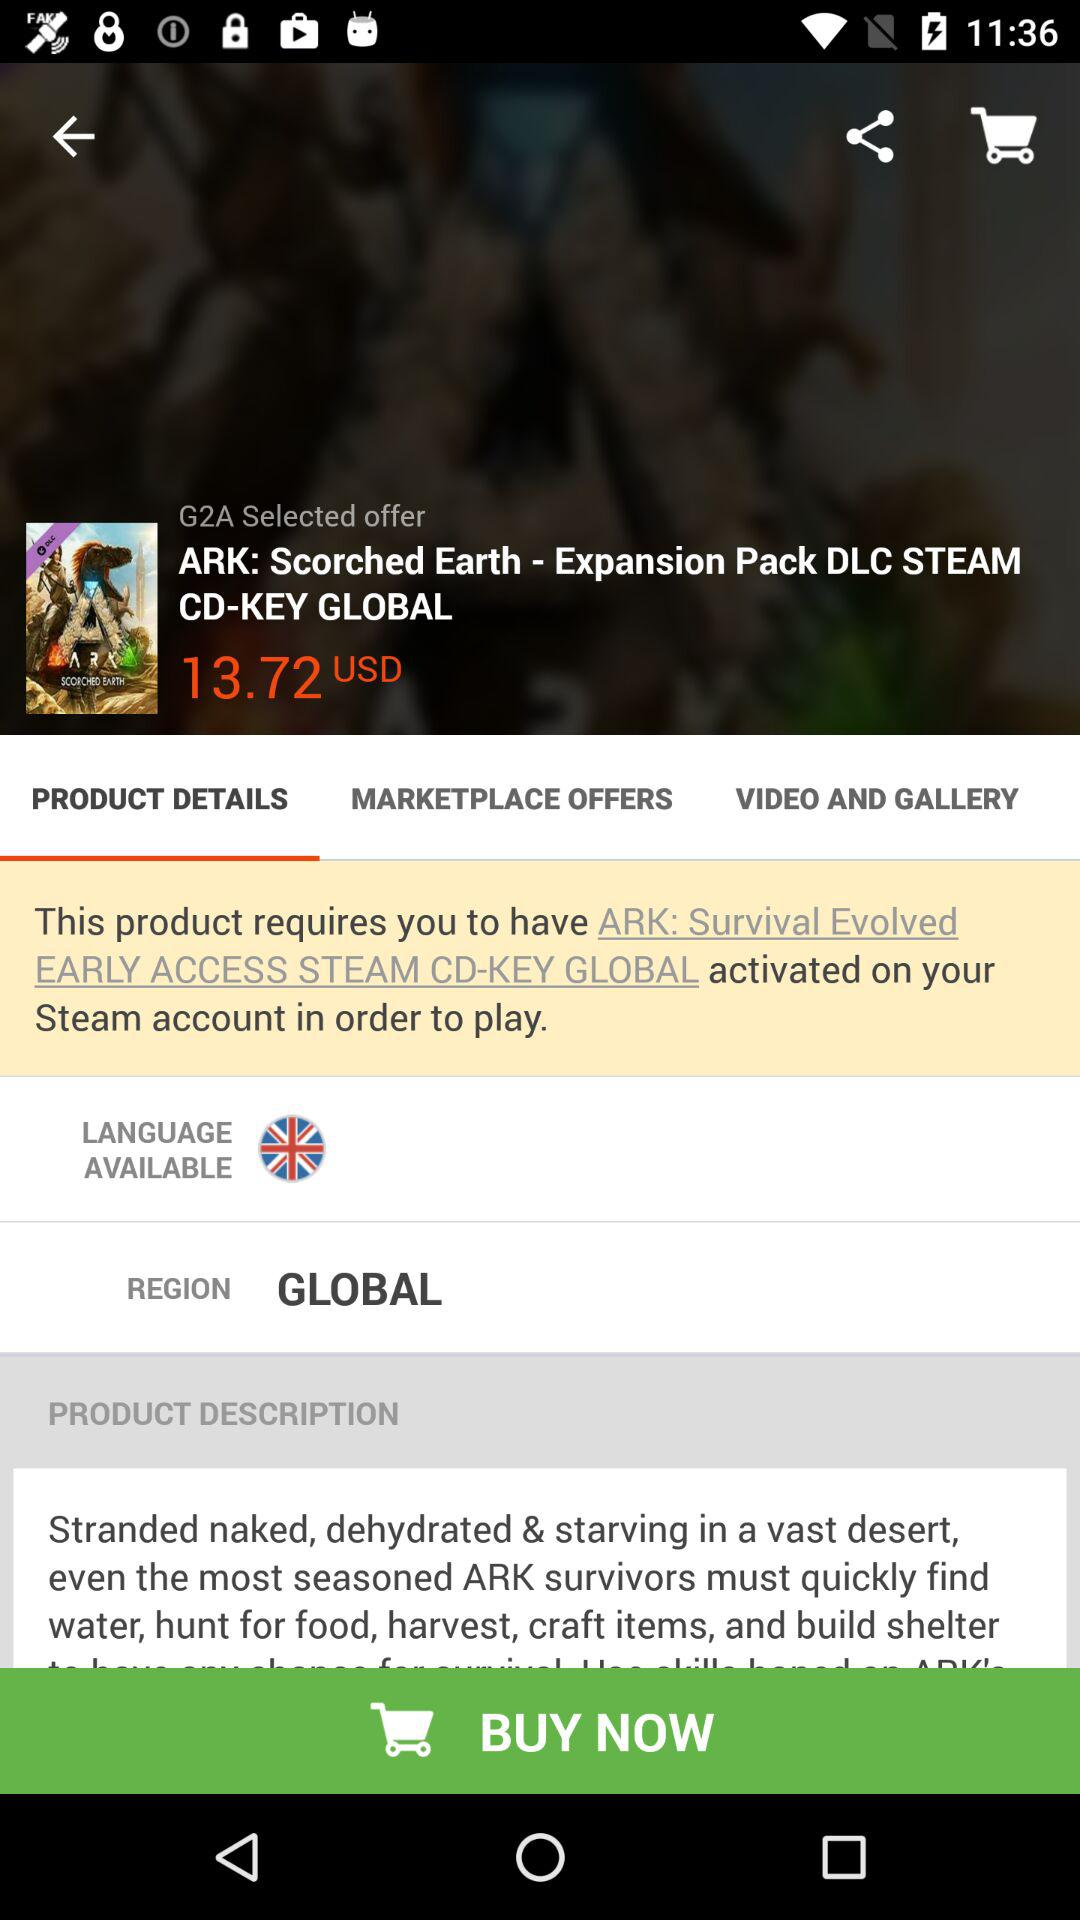What is the region? The region is global. 